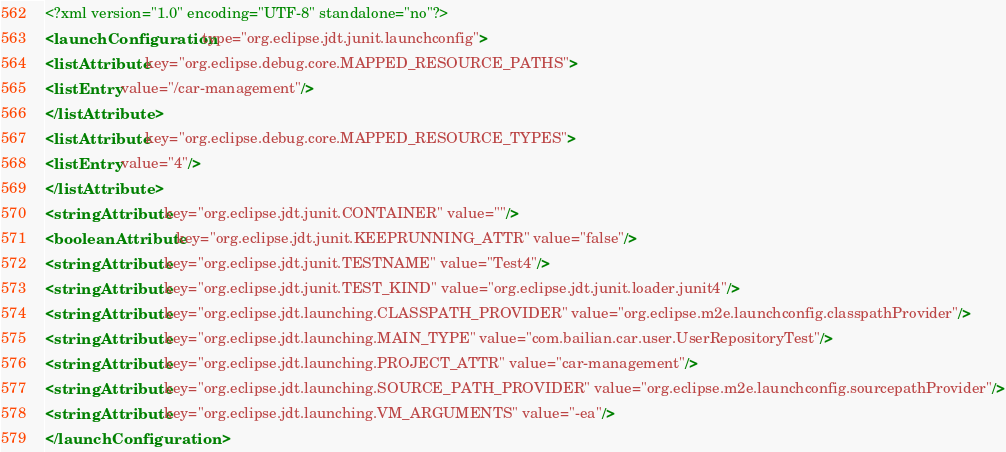Convert code to text. <code><loc_0><loc_0><loc_500><loc_500><_XML_><?xml version="1.0" encoding="UTF-8" standalone="no"?>
<launchConfiguration type="org.eclipse.jdt.junit.launchconfig">
<listAttribute key="org.eclipse.debug.core.MAPPED_RESOURCE_PATHS">
<listEntry value="/car-management"/>
</listAttribute>
<listAttribute key="org.eclipse.debug.core.MAPPED_RESOURCE_TYPES">
<listEntry value="4"/>
</listAttribute>
<stringAttribute key="org.eclipse.jdt.junit.CONTAINER" value=""/>
<booleanAttribute key="org.eclipse.jdt.junit.KEEPRUNNING_ATTR" value="false"/>
<stringAttribute key="org.eclipse.jdt.junit.TESTNAME" value="Test4"/>
<stringAttribute key="org.eclipse.jdt.junit.TEST_KIND" value="org.eclipse.jdt.junit.loader.junit4"/>
<stringAttribute key="org.eclipse.jdt.launching.CLASSPATH_PROVIDER" value="org.eclipse.m2e.launchconfig.classpathProvider"/>
<stringAttribute key="org.eclipse.jdt.launching.MAIN_TYPE" value="com.bailian.car.user.UserRepositoryTest"/>
<stringAttribute key="org.eclipse.jdt.launching.PROJECT_ATTR" value="car-management"/>
<stringAttribute key="org.eclipse.jdt.launching.SOURCE_PATH_PROVIDER" value="org.eclipse.m2e.launchconfig.sourcepathProvider"/>
<stringAttribute key="org.eclipse.jdt.launching.VM_ARGUMENTS" value="-ea"/>
</launchConfiguration>
</code> 